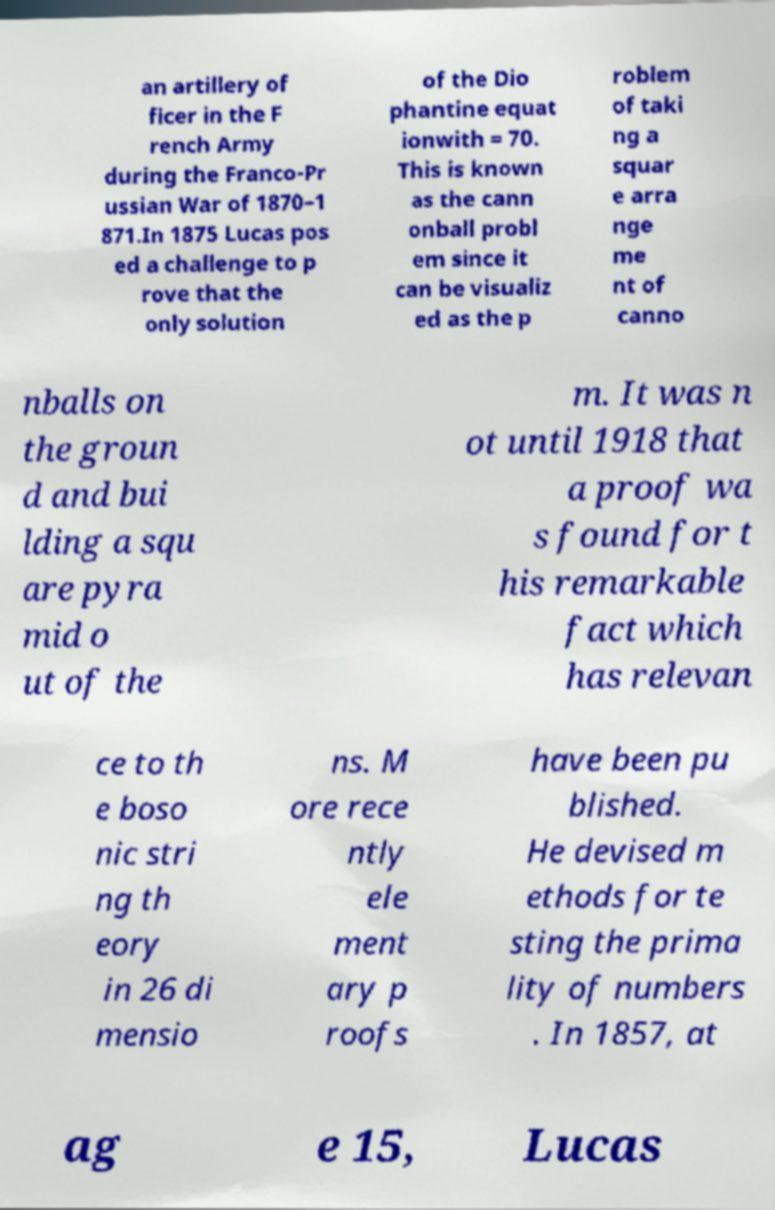For documentation purposes, I need the text within this image transcribed. Could you provide that? an artillery of ficer in the F rench Army during the Franco-Pr ussian War of 1870–1 871.In 1875 Lucas pos ed a challenge to p rove that the only solution of the Dio phantine equat ionwith = 70. This is known as the cann onball probl em since it can be visualiz ed as the p roblem of taki ng a squar e arra nge me nt of canno nballs on the groun d and bui lding a squ are pyra mid o ut of the m. It was n ot until 1918 that a proof wa s found for t his remarkable fact which has relevan ce to th e boso nic stri ng th eory in 26 di mensio ns. M ore rece ntly ele ment ary p roofs have been pu blished. He devised m ethods for te sting the prima lity of numbers . In 1857, at ag e 15, Lucas 